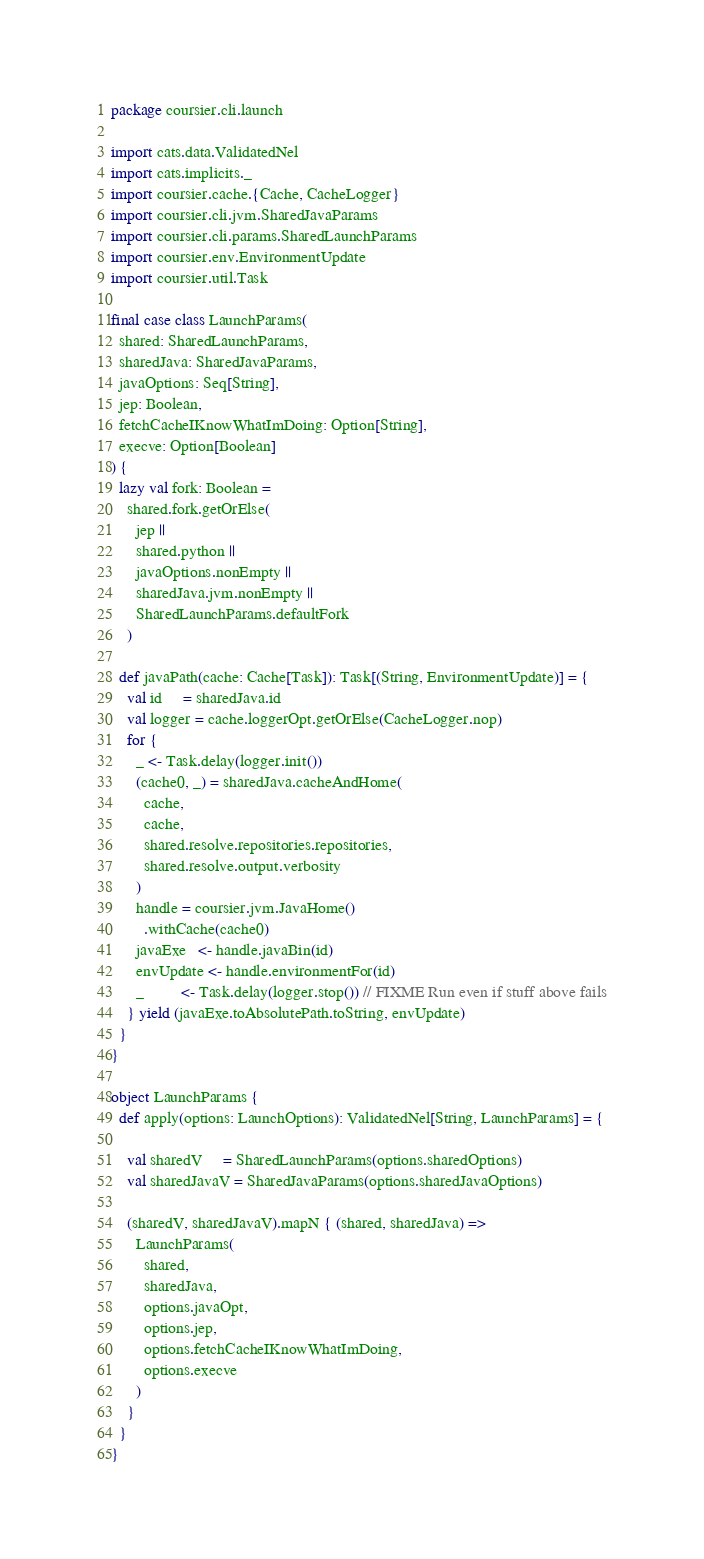<code> <loc_0><loc_0><loc_500><loc_500><_Scala_>package coursier.cli.launch

import cats.data.ValidatedNel
import cats.implicits._
import coursier.cache.{Cache, CacheLogger}
import coursier.cli.jvm.SharedJavaParams
import coursier.cli.params.SharedLaunchParams
import coursier.env.EnvironmentUpdate
import coursier.util.Task

final case class LaunchParams(
  shared: SharedLaunchParams,
  sharedJava: SharedJavaParams,
  javaOptions: Seq[String],
  jep: Boolean,
  fetchCacheIKnowWhatImDoing: Option[String],
  execve: Option[Boolean]
) {
  lazy val fork: Boolean =
    shared.fork.getOrElse(
      jep ||
      shared.python ||
      javaOptions.nonEmpty ||
      sharedJava.jvm.nonEmpty ||
      SharedLaunchParams.defaultFork
    )

  def javaPath(cache: Cache[Task]): Task[(String, EnvironmentUpdate)] = {
    val id     = sharedJava.id
    val logger = cache.loggerOpt.getOrElse(CacheLogger.nop)
    for {
      _ <- Task.delay(logger.init())
      (cache0, _) = sharedJava.cacheAndHome(
        cache,
        cache,
        shared.resolve.repositories.repositories,
        shared.resolve.output.verbosity
      )
      handle = coursier.jvm.JavaHome()
        .withCache(cache0)
      javaExe   <- handle.javaBin(id)
      envUpdate <- handle.environmentFor(id)
      _         <- Task.delay(logger.stop()) // FIXME Run even if stuff above fails
    } yield (javaExe.toAbsolutePath.toString, envUpdate)
  }
}

object LaunchParams {
  def apply(options: LaunchOptions): ValidatedNel[String, LaunchParams] = {

    val sharedV     = SharedLaunchParams(options.sharedOptions)
    val sharedJavaV = SharedJavaParams(options.sharedJavaOptions)

    (sharedV, sharedJavaV).mapN { (shared, sharedJava) =>
      LaunchParams(
        shared,
        sharedJava,
        options.javaOpt,
        options.jep,
        options.fetchCacheIKnowWhatImDoing,
        options.execve
      )
    }
  }
}
</code> 